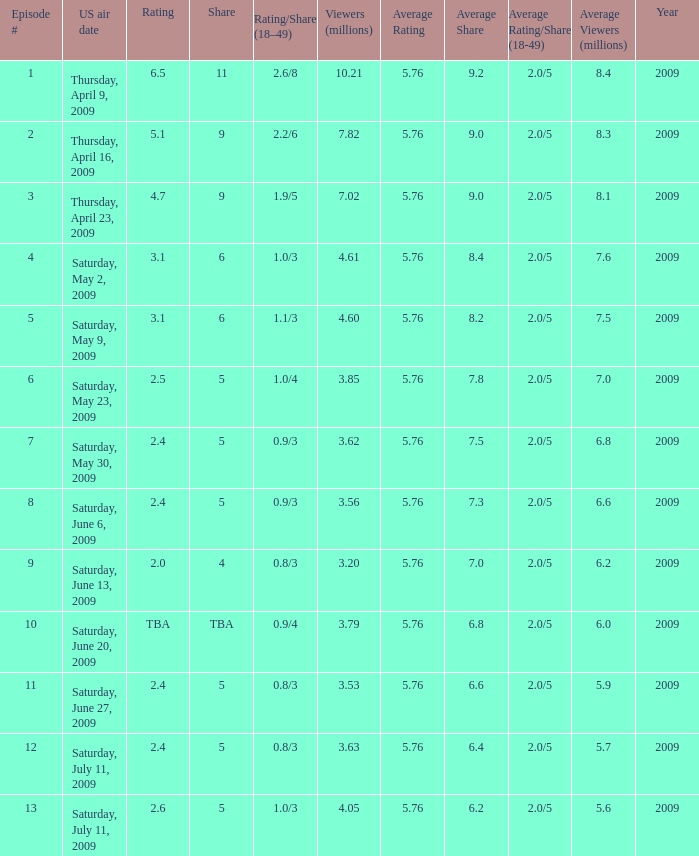What is the average number of million viewers that watched an episode before episode 11 with a share of 4? 3.2. Would you mind parsing the complete table? {'header': ['Episode #', 'US air date', 'Rating', 'Share', 'Rating/Share (18–49)', 'Viewers (millions)', 'Average Rating', 'Average Share', 'Average Rating/Share (18-49)', 'Average Viewers (millions)', 'Year'], 'rows': [['1', 'Thursday, April 9, 2009', '6.5', '11', '2.6/8', '10.21', '5.76', '9.2', '2.0/5', '8.4', '2009'], ['2', 'Thursday, April 16, 2009', '5.1', '9', '2.2/6', '7.82', '5.76', '9.0', '2.0/5', '8.3', '2009'], ['3', 'Thursday, April 23, 2009', '4.7', '9', '1.9/5', '7.02', '5.76', '9.0', '2.0/5', '8.1', '2009'], ['4', 'Saturday, May 2, 2009', '3.1', '6', '1.0/3', '4.61', '5.76', '8.4', '2.0/5', '7.6', '2009'], ['5', 'Saturday, May 9, 2009', '3.1', '6', '1.1/3', '4.60', '5.76', '8.2', '2.0/5', '7.5', '2009'], ['6', 'Saturday, May 23, 2009', '2.5', '5', '1.0/4', '3.85', '5.76', '7.8', '2.0/5', '7.0', '2009'], ['7', 'Saturday, May 30, 2009', '2.4', '5', '0.9/3', '3.62', '5.76', '7.5', '2.0/5', '6.8', '2009'], ['8', 'Saturday, June 6, 2009', '2.4', '5', '0.9/3', '3.56', '5.76', '7.3', '2.0/5', '6.6', '2009'], ['9', 'Saturday, June 13, 2009', '2.0', '4', '0.8/3', '3.20', '5.76', '7.0', '2.0/5', '6.2', '2009'], ['10', 'Saturday, June 20, 2009', 'TBA', 'TBA', '0.9/4', '3.79', '5.76', '6.8', '2.0/5', '6.0', '2009'], ['11', 'Saturday, June 27, 2009', '2.4', '5', '0.8/3', '3.53', '5.76', '6.6', '2.0/5', '5.9', '2009'], ['12', 'Saturday, July 11, 2009', '2.4', '5', '0.8/3', '3.63', '5.76', '6.4', '2.0/5', '5.7', '2009'], ['13', 'Saturday, July 11, 2009', '2.6', '5', '1.0/3', '4.05', '5.76', '6.2', '2.0/5', '5.6', '2009']]} 